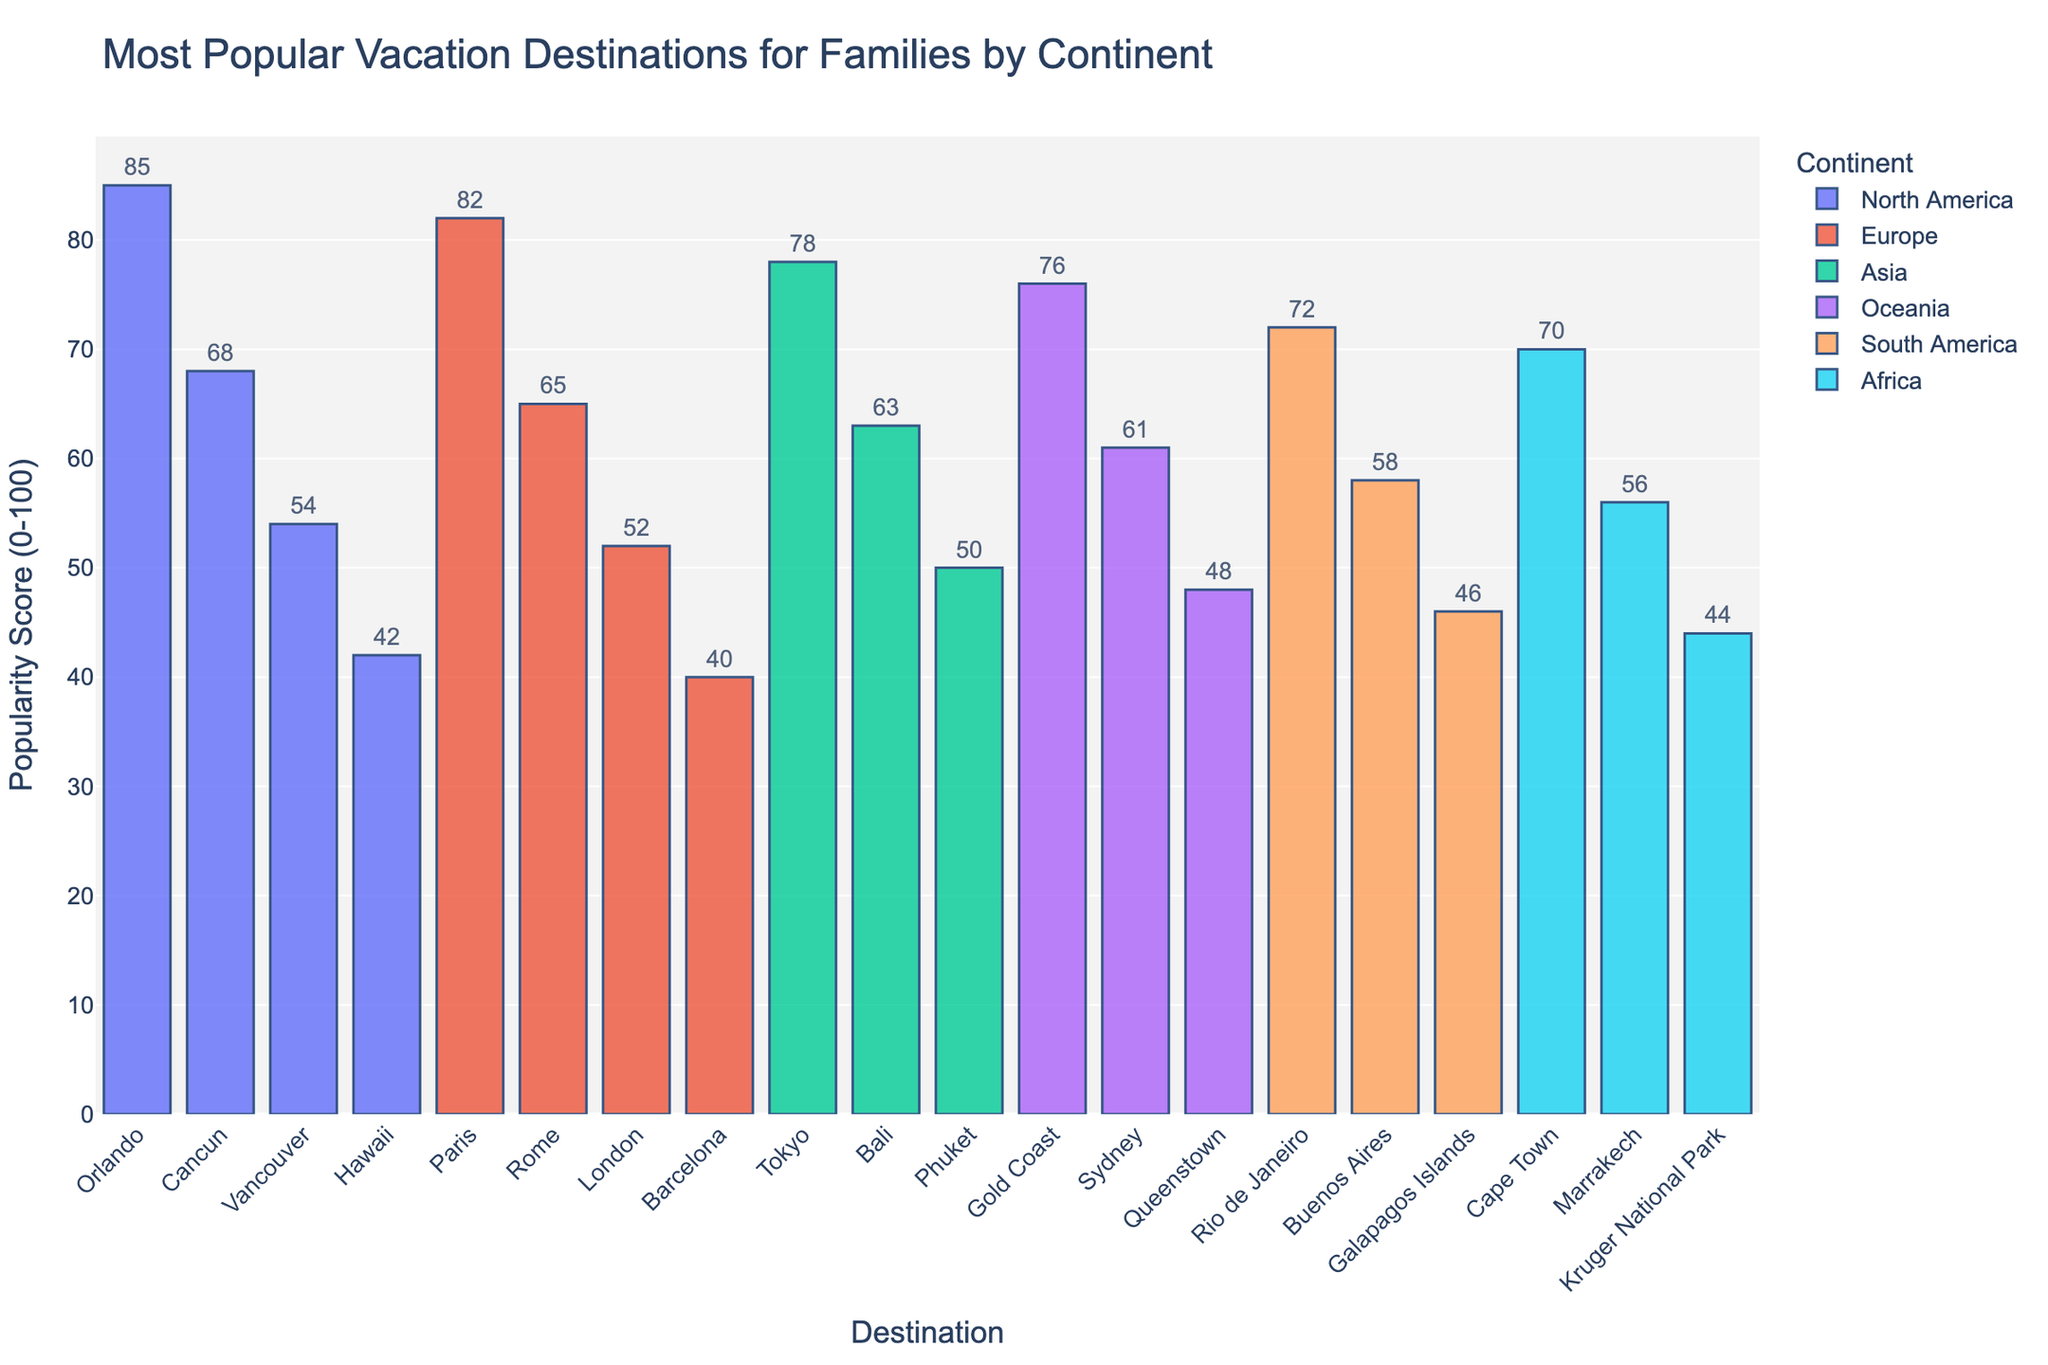What's the most popular vacation destination for families in North America? By looking at the tallest bar colored for North America on the chart, Orlando has the highest point at 85 in Popularity Score.
Answer: Orlando What's the difference in the Popularity Score between the top destinations in Europe and Asia? Identify the top destinations for Europe and Asia (Paris with 82 and Tokyo with 78), subtract the second from the first: 82 - 78 = 4.
Answer: 4 Which continent has the vacation destination with the lowest Popularity Score? Find the smallest bar in the chart, which is colored for Africa (Kruger National Park with a score of 44).
Answer: Africa Which destination in Oceania ranks higher in popularity: Sydney or Queenstown? Compare the heights of the bars for Sydney (61) and Queenstown (48); Sydney's bar is higher.
Answer: Sydney What is the average Popularity Score of the top three vacation destinations? Find the scores of the top three destinations (Orlando - 85, Paris - 82, Tokyo - 78). Calculate the average: (85 + 82 + 78) / 3 = 81.67.
Answer: 81.67 What is the total Popularity Score of all vacation destinations in South America? Add up the scores for destinations in South America: Rio de Janeiro (72), Buenos Aires (58), and Galapagos Islands (46). 72 + 58 + 46 = 176.
Answer: 176 Which destination in Europe has the lowest Popularity Score, and what is it? Find the shortest bar among the destinations in Europe, which is Barcelona with a score of 40.
Answer: Barcelona Is the Popularity Score of Cancun closer to the highest score or the lowest score among all destinations? The highest score is 85 (Orlando), the lowest is 40 (Barcelona). Calculate the differences: 85 - 68 = 17 (high), 68 - 40 = 28 (low). 17 < 28, so closer to 85.
Answer: Highest score What's the combined Popularity Score of the top vacation destinations in Africa and Oceania? Find the top destinations in Africa (Cape Town - 70) and Oceania (Gold Coast - 76). Add their scores: 70 + 76 = 146.
Answer: 146 Which continent has more destinations with a Popularity Score above 60: North America or Europe? Count the destinations above 60 for each: North America (Orlando - 85, Cancun - 68) = 2; Europe (Paris - 82, Rome - 65) = 2.
Answer: Equal 